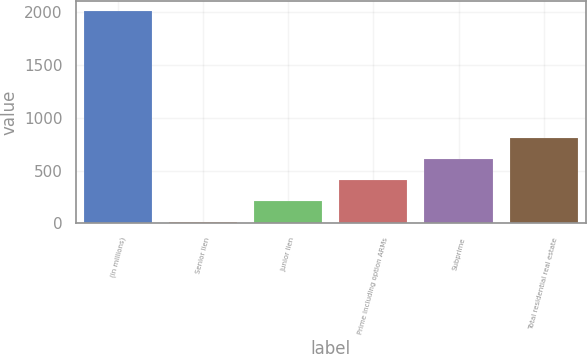Convert chart to OTSL. <chart><loc_0><loc_0><loc_500><loc_500><bar_chart><fcel>(in millions)<fcel>Senior lien<fcel>Junior lien<fcel>Prime including option ARMs<fcel>Subprime<fcel>Total residential real estate<nl><fcel>2011<fcel>10<fcel>210.1<fcel>410.2<fcel>610.3<fcel>810.4<nl></chart> 